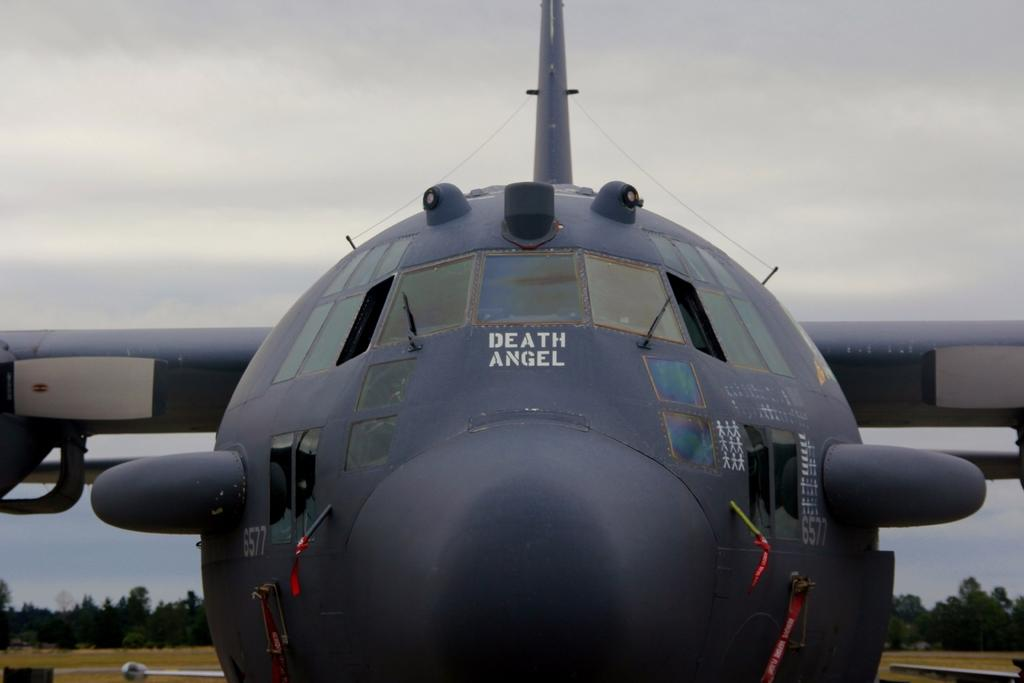<image>
Relay a brief, clear account of the picture shown. An up close, face forward picture of the plane the Death Angel. 